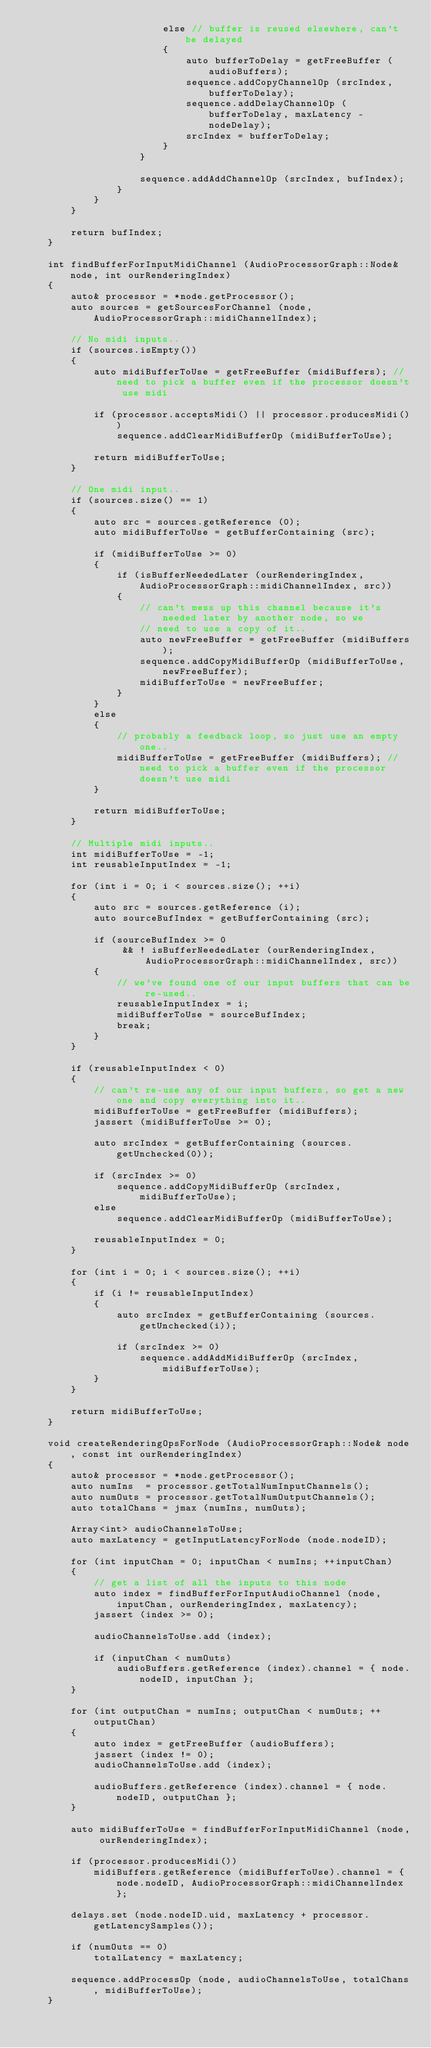<code> <loc_0><loc_0><loc_500><loc_500><_C++_>                        else // buffer is reused elsewhere, can't be delayed
                        {
                            auto bufferToDelay = getFreeBuffer (audioBuffers);
                            sequence.addCopyChannelOp (srcIndex, bufferToDelay);
                            sequence.addDelayChannelOp (bufferToDelay, maxLatency - nodeDelay);
                            srcIndex = bufferToDelay;
                        }
                    }

                    sequence.addAddChannelOp (srcIndex, bufIndex);
                }
            }
        }

        return bufIndex;
    }

    int findBufferForInputMidiChannel (AudioProcessorGraph::Node& node, int ourRenderingIndex)
    {
        auto& processor = *node.getProcessor();
        auto sources = getSourcesForChannel (node, AudioProcessorGraph::midiChannelIndex);

        // No midi inputs..
        if (sources.isEmpty())
        {
            auto midiBufferToUse = getFreeBuffer (midiBuffers); // need to pick a buffer even if the processor doesn't use midi

            if (processor.acceptsMidi() || processor.producesMidi())
                sequence.addClearMidiBufferOp (midiBufferToUse);

            return midiBufferToUse;
        }

        // One midi input..
        if (sources.size() == 1)
        {
            auto src = sources.getReference (0);
            auto midiBufferToUse = getBufferContaining (src);

            if (midiBufferToUse >= 0)
            {
                if (isBufferNeededLater (ourRenderingIndex, AudioProcessorGraph::midiChannelIndex, src))
                {
                    // can't mess up this channel because it's needed later by another node, so we
                    // need to use a copy of it..
                    auto newFreeBuffer = getFreeBuffer (midiBuffers);
                    sequence.addCopyMidiBufferOp (midiBufferToUse, newFreeBuffer);
                    midiBufferToUse = newFreeBuffer;
                }
            }
            else
            {
                // probably a feedback loop, so just use an empty one..
                midiBufferToUse = getFreeBuffer (midiBuffers); // need to pick a buffer even if the processor doesn't use midi
            }

            return midiBufferToUse;
        }

        // Multiple midi inputs..
        int midiBufferToUse = -1;
        int reusableInputIndex = -1;

        for (int i = 0; i < sources.size(); ++i)
        {
            auto src = sources.getReference (i);
            auto sourceBufIndex = getBufferContaining (src);

            if (sourceBufIndex >= 0
                 && ! isBufferNeededLater (ourRenderingIndex, AudioProcessorGraph::midiChannelIndex, src))
            {
                // we've found one of our input buffers that can be re-used..
                reusableInputIndex = i;
                midiBufferToUse = sourceBufIndex;
                break;
            }
        }

        if (reusableInputIndex < 0)
        {
            // can't re-use any of our input buffers, so get a new one and copy everything into it..
            midiBufferToUse = getFreeBuffer (midiBuffers);
            jassert (midiBufferToUse >= 0);

            auto srcIndex = getBufferContaining (sources.getUnchecked(0));

            if (srcIndex >= 0)
                sequence.addCopyMidiBufferOp (srcIndex, midiBufferToUse);
            else
                sequence.addClearMidiBufferOp (midiBufferToUse);

            reusableInputIndex = 0;
        }

        for (int i = 0; i < sources.size(); ++i)
        {
            if (i != reusableInputIndex)
            {
                auto srcIndex = getBufferContaining (sources.getUnchecked(i));

                if (srcIndex >= 0)
                    sequence.addAddMidiBufferOp (srcIndex, midiBufferToUse);
            }
        }

        return midiBufferToUse;
    }

    void createRenderingOpsForNode (AudioProcessorGraph::Node& node, const int ourRenderingIndex)
    {
        auto& processor = *node.getProcessor();
        auto numIns  = processor.getTotalNumInputChannels();
        auto numOuts = processor.getTotalNumOutputChannels();
        auto totalChans = jmax (numIns, numOuts);

        Array<int> audioChannelsToUse;
        auto maxLatency = getInputLatencyForNode (node.nodeID);

        for (int inputChan = 0; inputChan < numIns; ++inputChan)
        {
            // get a list of all the inputs to this node
            auto index = findBufferForInputAudioChannel (node, inputChan, ourRenderingIndex, maxLatency);
            jassert (index >= 0);

            audioChannelsToUse.add (index);

            if (inputChan < numOuts)
                audioBuffers.getReference (index).channel = { node.nodeID, inputChan };
        }

        for (int outputChan = numIns; outputChan < numOuts; ++outputChan)
        {
            auto index = getFreeBuffer (audioBuffers);
            jassert (index != 0);
            audioChannelsToUse.add (index);

            audioBuffers.getReference (index).channel = { node.nodeID, outputChan };
        }

        auto midiBufferToUse = findBufferForInputMidiChannel (node, ourRenderingIndex);

        if (processor.producesMidi())
            midiBuffers.getReference (midiBufferToUse).channel = { node.nodeID, AudioProcessorGraph::midiChannelIndex };

        delays.set (node.nodeID.uid, maxLatency + processor.getLatencySamples());

        if (numOuts == 0)
            totalLatency = maxLatency;

        sequence.addProcessOp (node, audioChannelsToUse, totalChans, midiBufferToUse);
    }</code> 